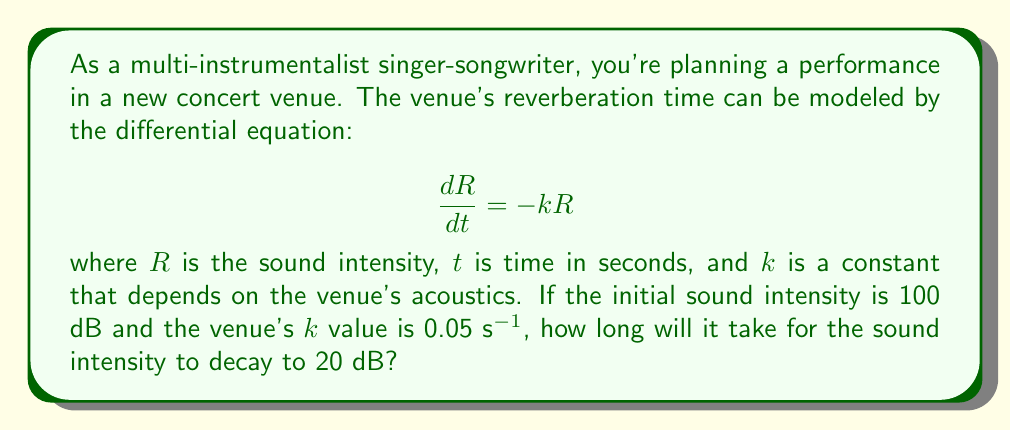Help me with this question. To solve this problem, we need to follow these steps:

1) The given differential equation is a first-order separable equation. Its general solution is:

   $$R = Ce^{-kt}$$

   where $C$ is a constant determined by the initial conditions.

2) We're given that the initial sound intensity $R_0 = 100$ dB at $t = 0$. Let's use this to find $C$:

   $$100 = Ce^{-k(0)} = C$$

3) Now our specific solution is:

   $$R = 100e^{-0.05t}$$

4) We want to find $t$ when $R = 20$ dB. Let's substitute these values:

   $$20 = 100e^{-0.05t}$$

5) Divide both sides by 100:

   $$0.2 = e^{-0.05t}$$

6) Take the natural log of both sides:

   $$\ln(0.2) = -0.05t$$

7) Solve for $t$:

   $$t = -\frac{\ln(0.2)}{0.05} \approx 32.19$$

Therefore, it will take approximately 32.19 seconds for the sound to decay from 100 dB to 20 dB.
Answer: $t \approx 32.19$ seconds 